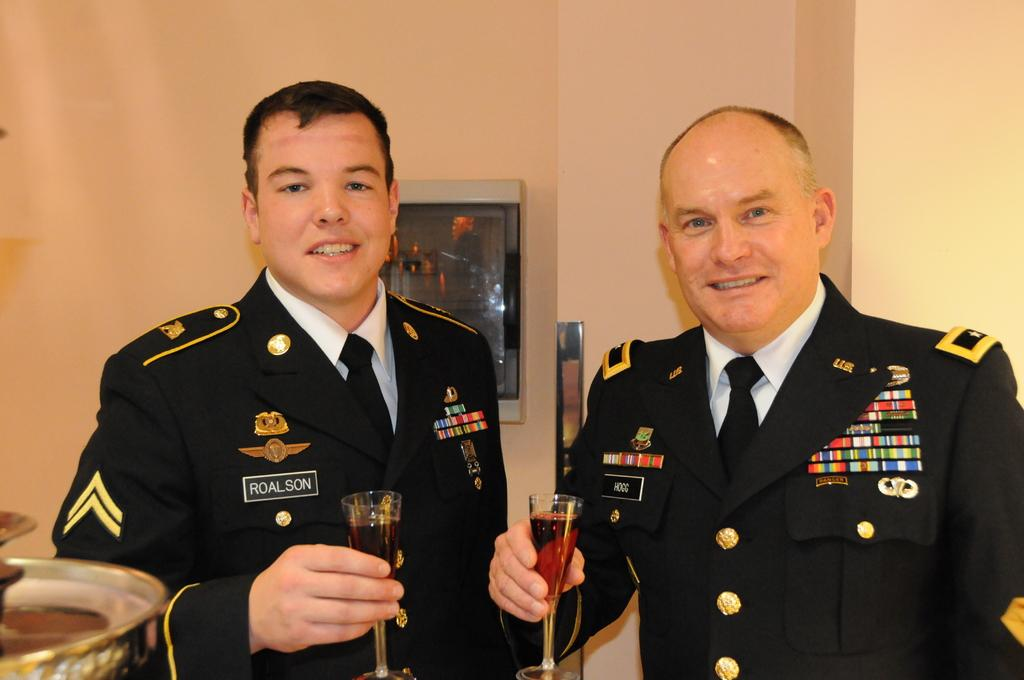How many people are in the image? There are two men in the image. What are the men holding in the image? The men are holding juice glasses. Can you describe the object in the center of the image on the wall? There is a box in the center of the image on the wall. What type of paper is the men using to express their desires in the image? There is no paper or expression of desires present in the image. 